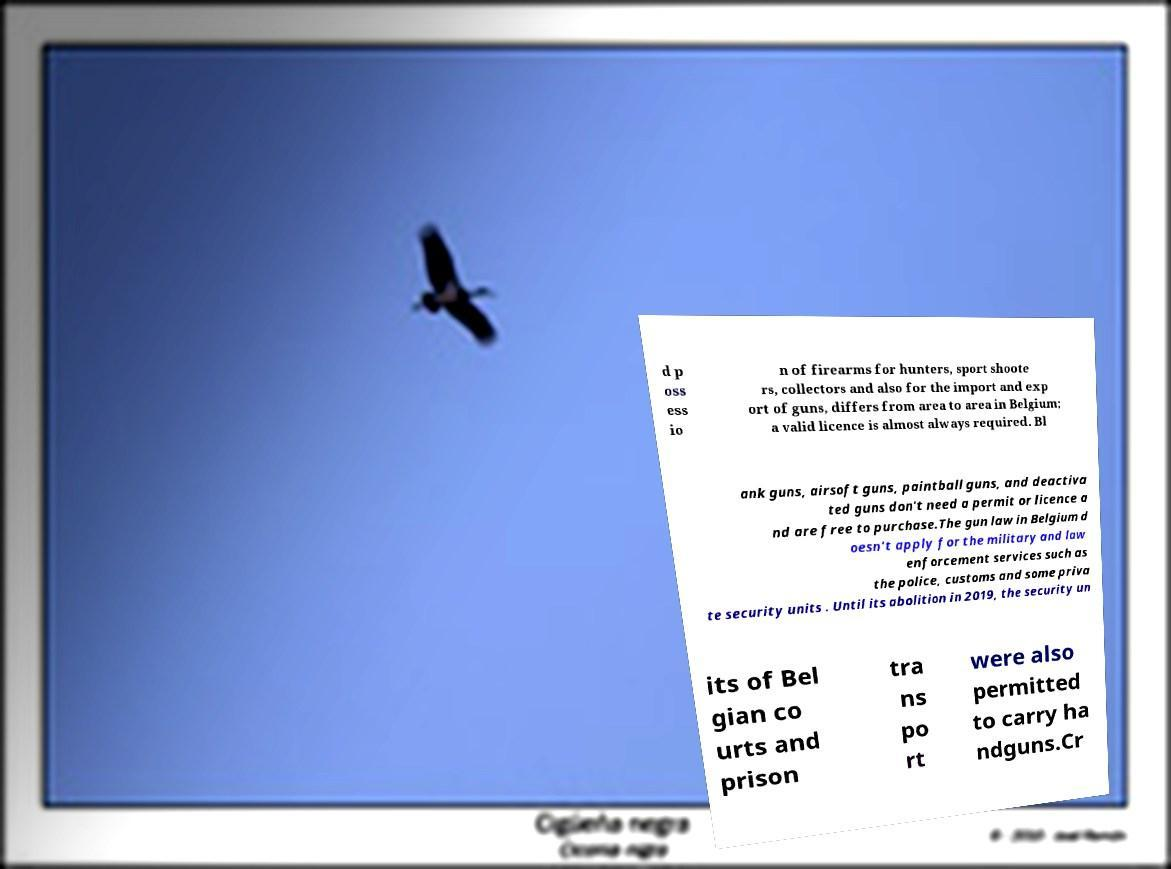Please identify and transcribe the text found in this image. d p oss ess io n of firearms for hunters, sport shoote rs, collectors and also for the import and exp ort of guns, differs from area to area in Belgium; a valid licence is almost always required. Bl ank guns, airsoft guns, paintball guns, and deactiva ted guns don't need a permit or licence a nd are free to purchase.The gun law in Belgium d oesn't apply for the military and law enforcement services such as the police, customs and some priva te security units . Until its abolition in 2019, the security un its of Bel gian co urts and prison tra ns po rt were also permitted to carry ha ndguns.Cr 